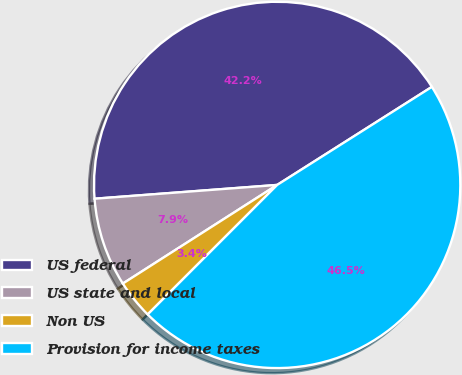Convert chart. <chart><loc_0><loc_0><loc_500><loc_500><pie_chart><fcel>US federal<fcel>US state and local<fcel>Non US<fcel>Provision for income taxes<nl><fcel>42.21%<fcel>7.85%<fcel>3.45%<fcel>46.49%<nl></chart> 